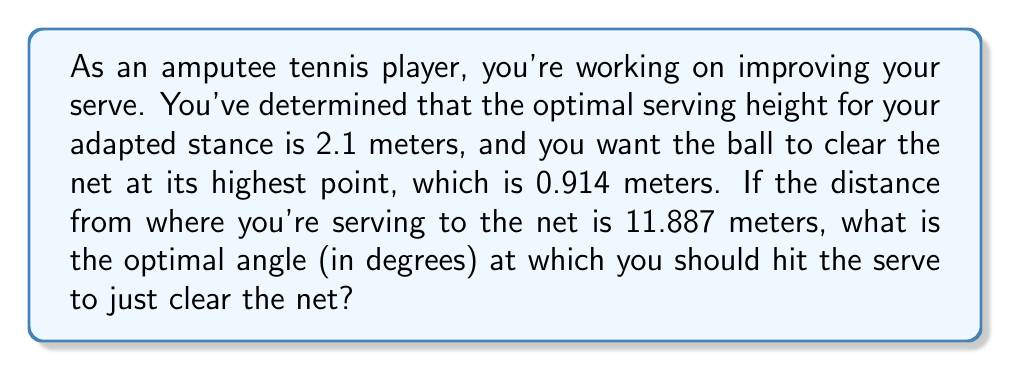What is the answer to this math problem? Let's approach this step-by-step using trigonometry:

1) First, let's visualize the problem:

[asy]
import geometry;

size(200);
pair A = (0,0), B = (11.887,0), C = (11.887,0.914), D = (0,2.1);
draw(A--B--C--D--A);
label("2.1m", D, W);
label("11.887m", (A--B), S);
label("0.914m", C, E);
label("θ", A, NE);
[/asy]

2) We can treat this as a right triangle problem. The angle we're looking for is the angle at which the ball leaves the racket (θ).

3) We know:
   - The adjacent side (distance to net) = 11.887 m
   - The opposite side = 2.1 m (serving height) - 0.914 m (net height) = 1.186 m

4) We can use the tangent function to find the angle:

   $$\tan(\theta) = \frac{\text{opposite}}{\text{adjacent}} = \frac{1.186}{11.887}$$

5) To find θ, we need to use the inverse tangent (arctan or $\tan^{-1}$):

   $$\theta = \tan^{-1}\left(\frac{1.186}{11.887}\right)$$

6) Using a calculator or computer:

   $$\theta \approx 5.7015^\circ$$

7) Rounding to two decimal places:

   $$\theta \approx 5.70^\circ$$

This angle will allow the ball to just clear the net at its highest point.
Answer: $5.70^\circ$ 